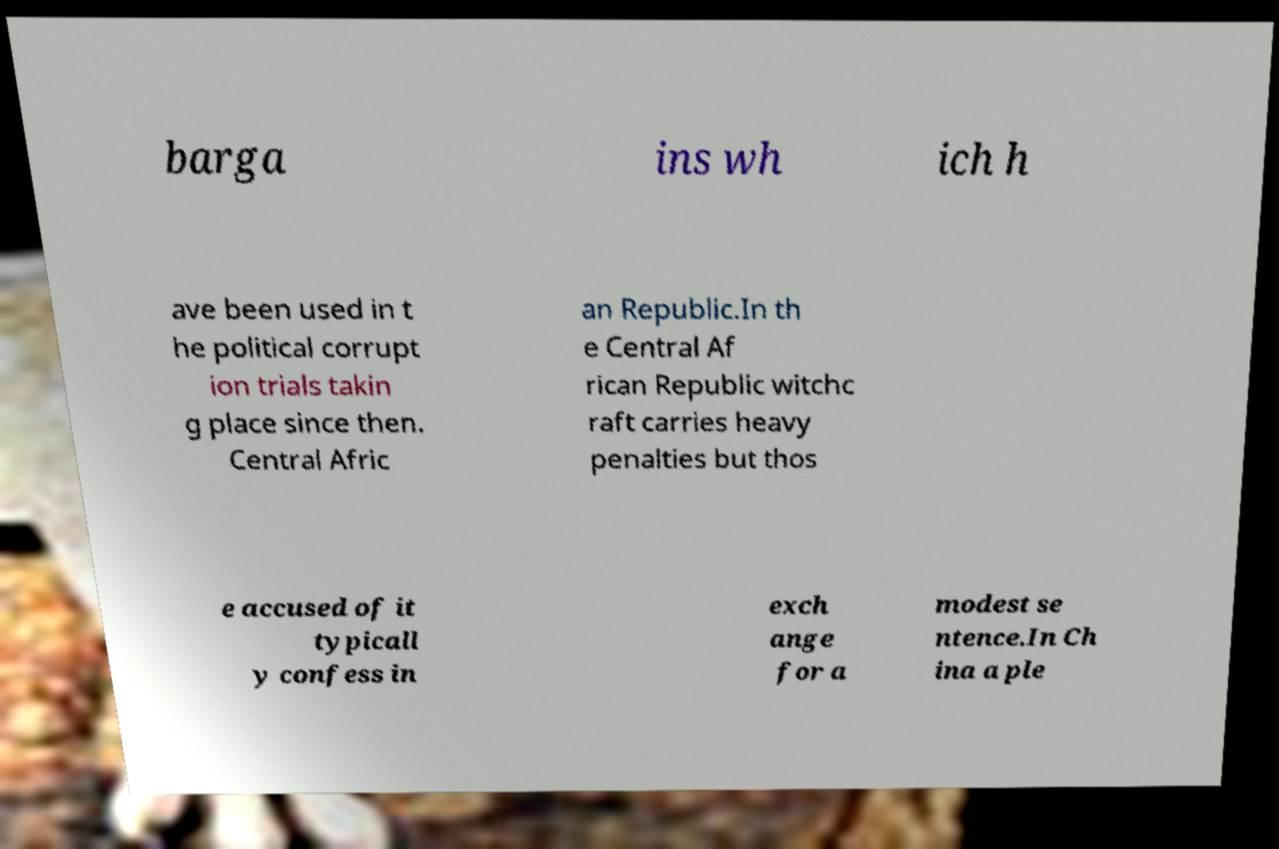There's text embedded in this image that I need extracted. Can you transcribe it verbatim? barga ins wh ich h ave been used in t he political corrupt ion trials takin g place since then. Central Afric an Republic.In th e Central Af rican Republic witchc raft carries heavy penalties but thos e accused of it typicall y confess in exch ange for a modest se ntence.In Ch ina a ple 